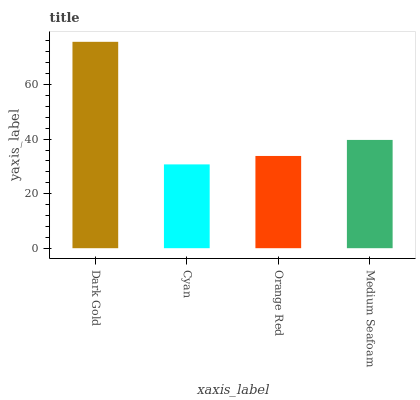Is Cyan the minimum?
Answer yes or no. Yes. Is Dark Gold the maximum?
Answer yes or no. Yes. Is Orange Red the minimum?
Answer yes or no. No. Is Orange Red the maximum?
Answer yes or no. No. Is Orange Red greater than Cyan?
Answer yes or no. Yes. Is Cyan less than Orange Red?
Answer yes or no. Yes. Is Cyan greater than Orange Red?
Answer yes or no. No. Is Orange Red less than Cyan?
Answer yes or no. No. Is Medium Seafoam the high median?
Answer yes or no. Yes. Is Orange Red the low median?
Answer yes or no. Yes. Is Dark Gold the high median?
Answer yes or no. No. Is Dark Gold the low median?
Answer yes or no. No. 